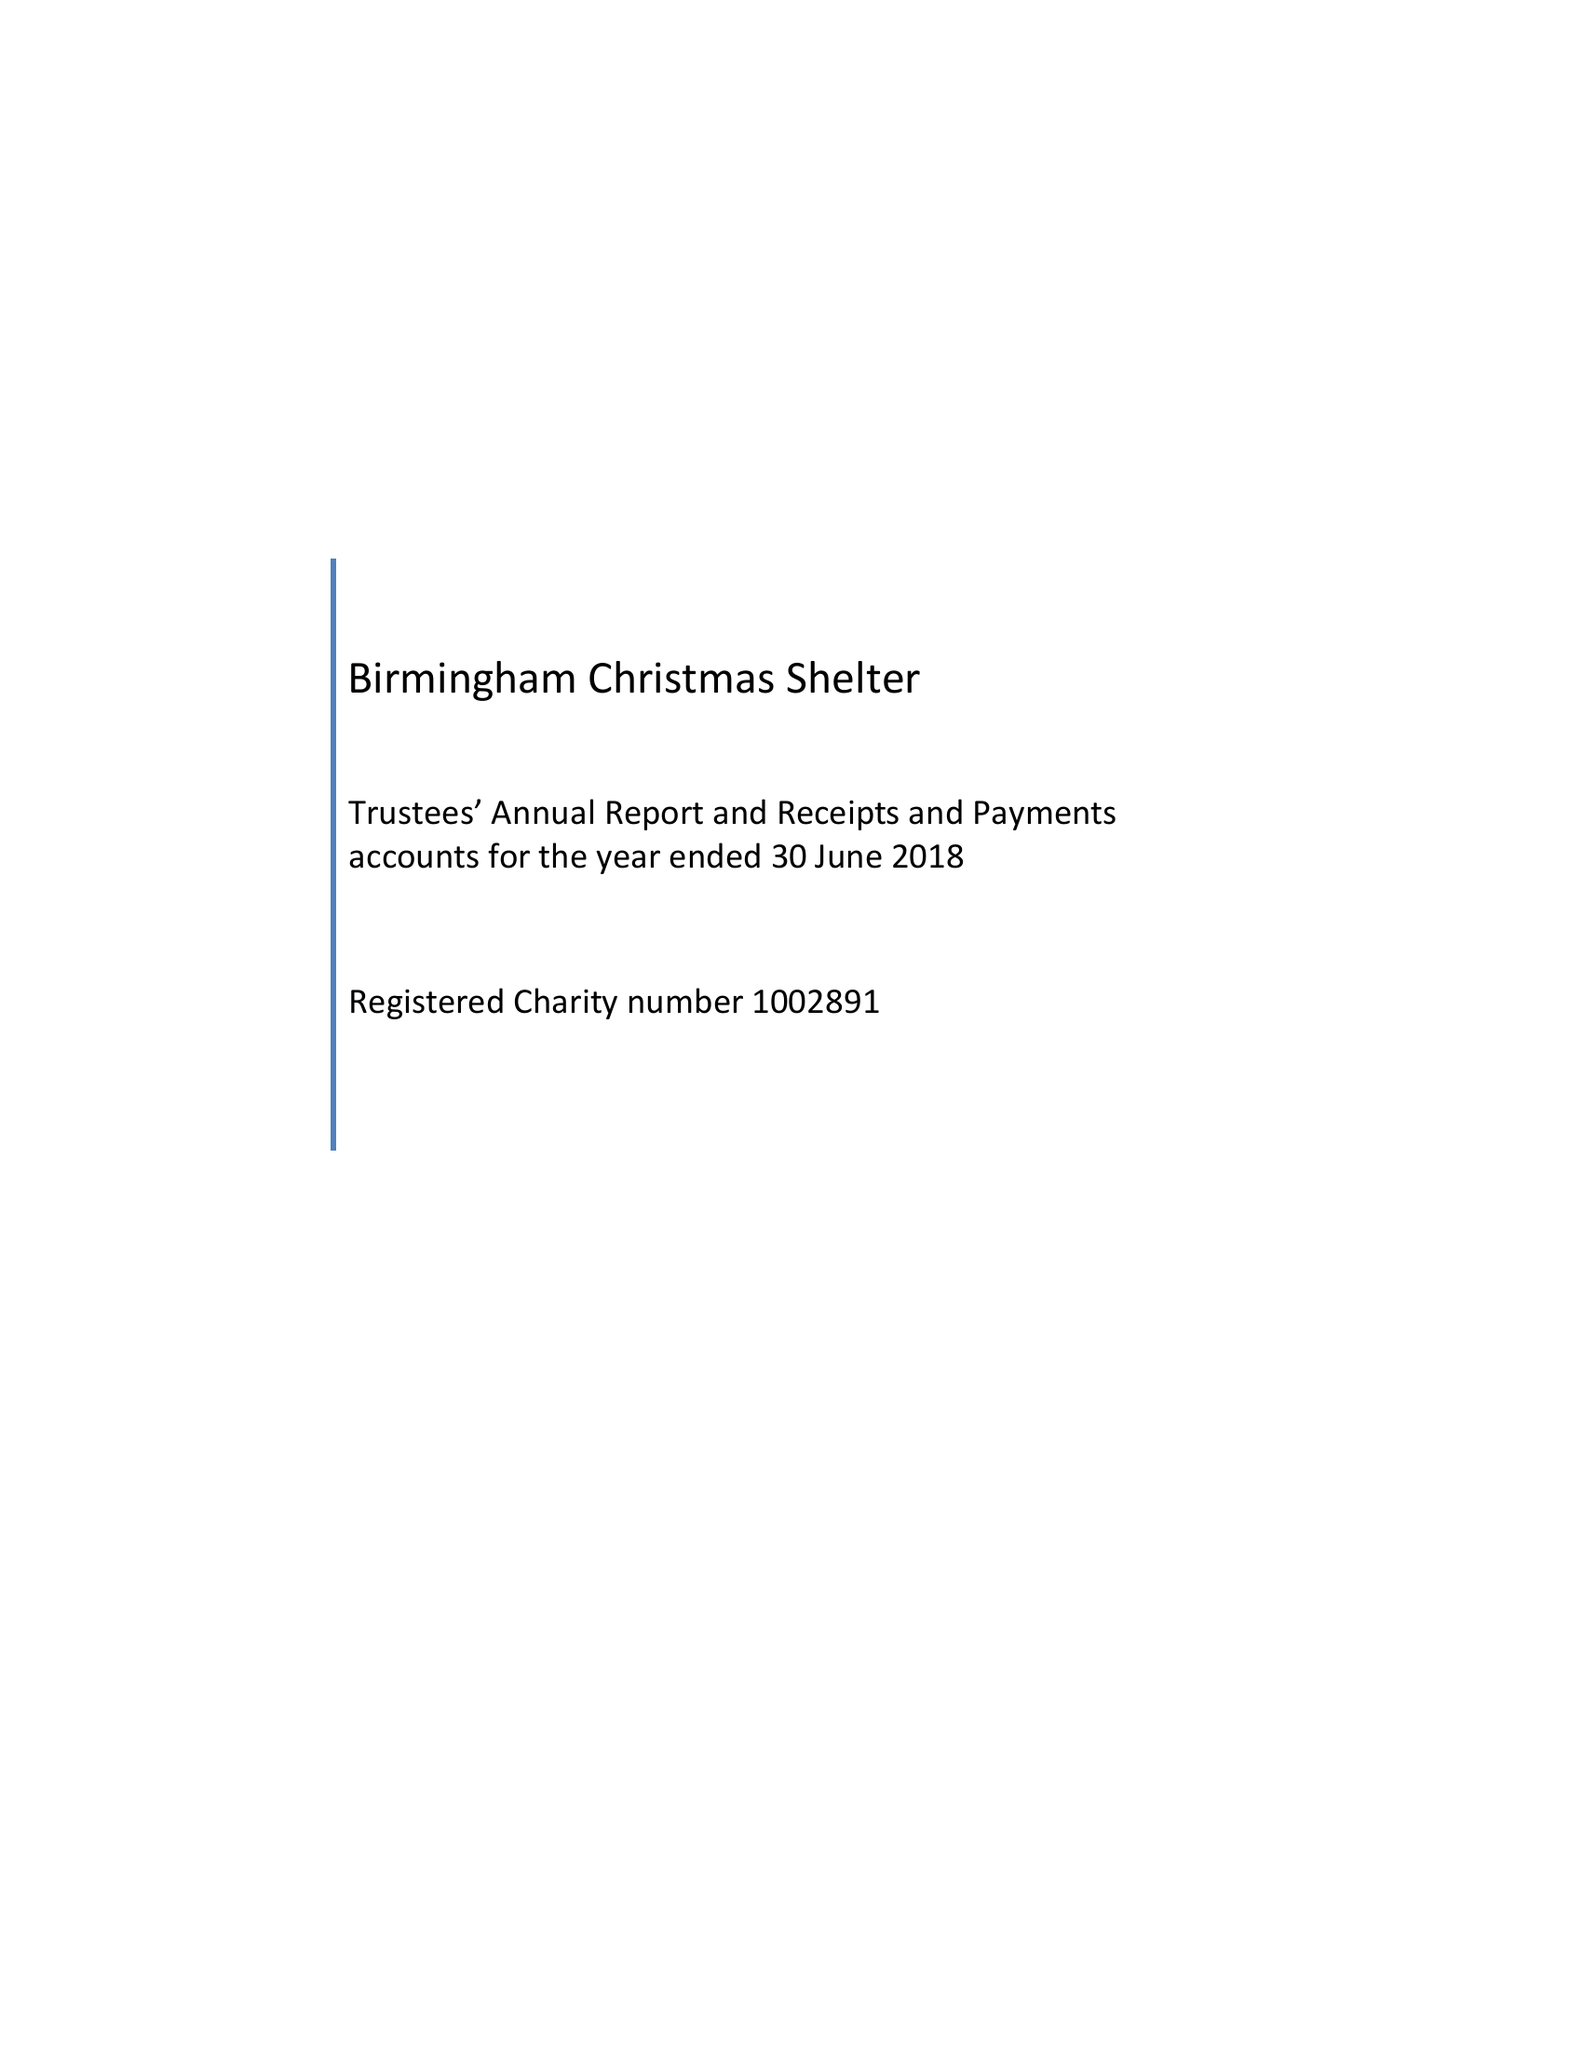What is the value for the charity_number?
Answer the question using a single word or phrase. 1002891 